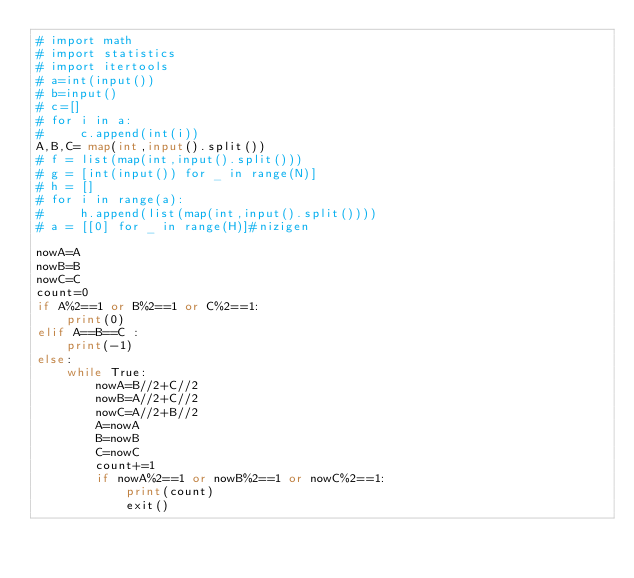Convert code to text. <code><loc_0><loc_0><loc_500><loc_500><_Python_># import math
# import statistics
# import itertools
# a=int(input())
# b=input()
# c=[]
# for i in a:
#     c.append(int(i))
A,B,C= map(int,input().split())
# f = list(map(int,input().split()))
# g = [int(input()) for _ in range(N)]
# h = []
# for i in range(a):
#     h.append(list(map(int,input().split())))
# a = [[0] for _ in range(H)]#nizigen

nowA=A
nowB=B
nowC=C
count=0
if A%2==1 or B%2==1 or C%2==1:
    print(0)
elif A==B==C :
    print(-1)
else:
    while True:
        nowA=B//2+C//2
        nowB=A//2+C//2
        nowC=A//2+B//2
        A=nowA
        B=nowB
        C=nowC
        count+=1
        if nowA%2==1 or nowB%2==1 or nowC%2==1:
            print(count)
            exit()
</code> 